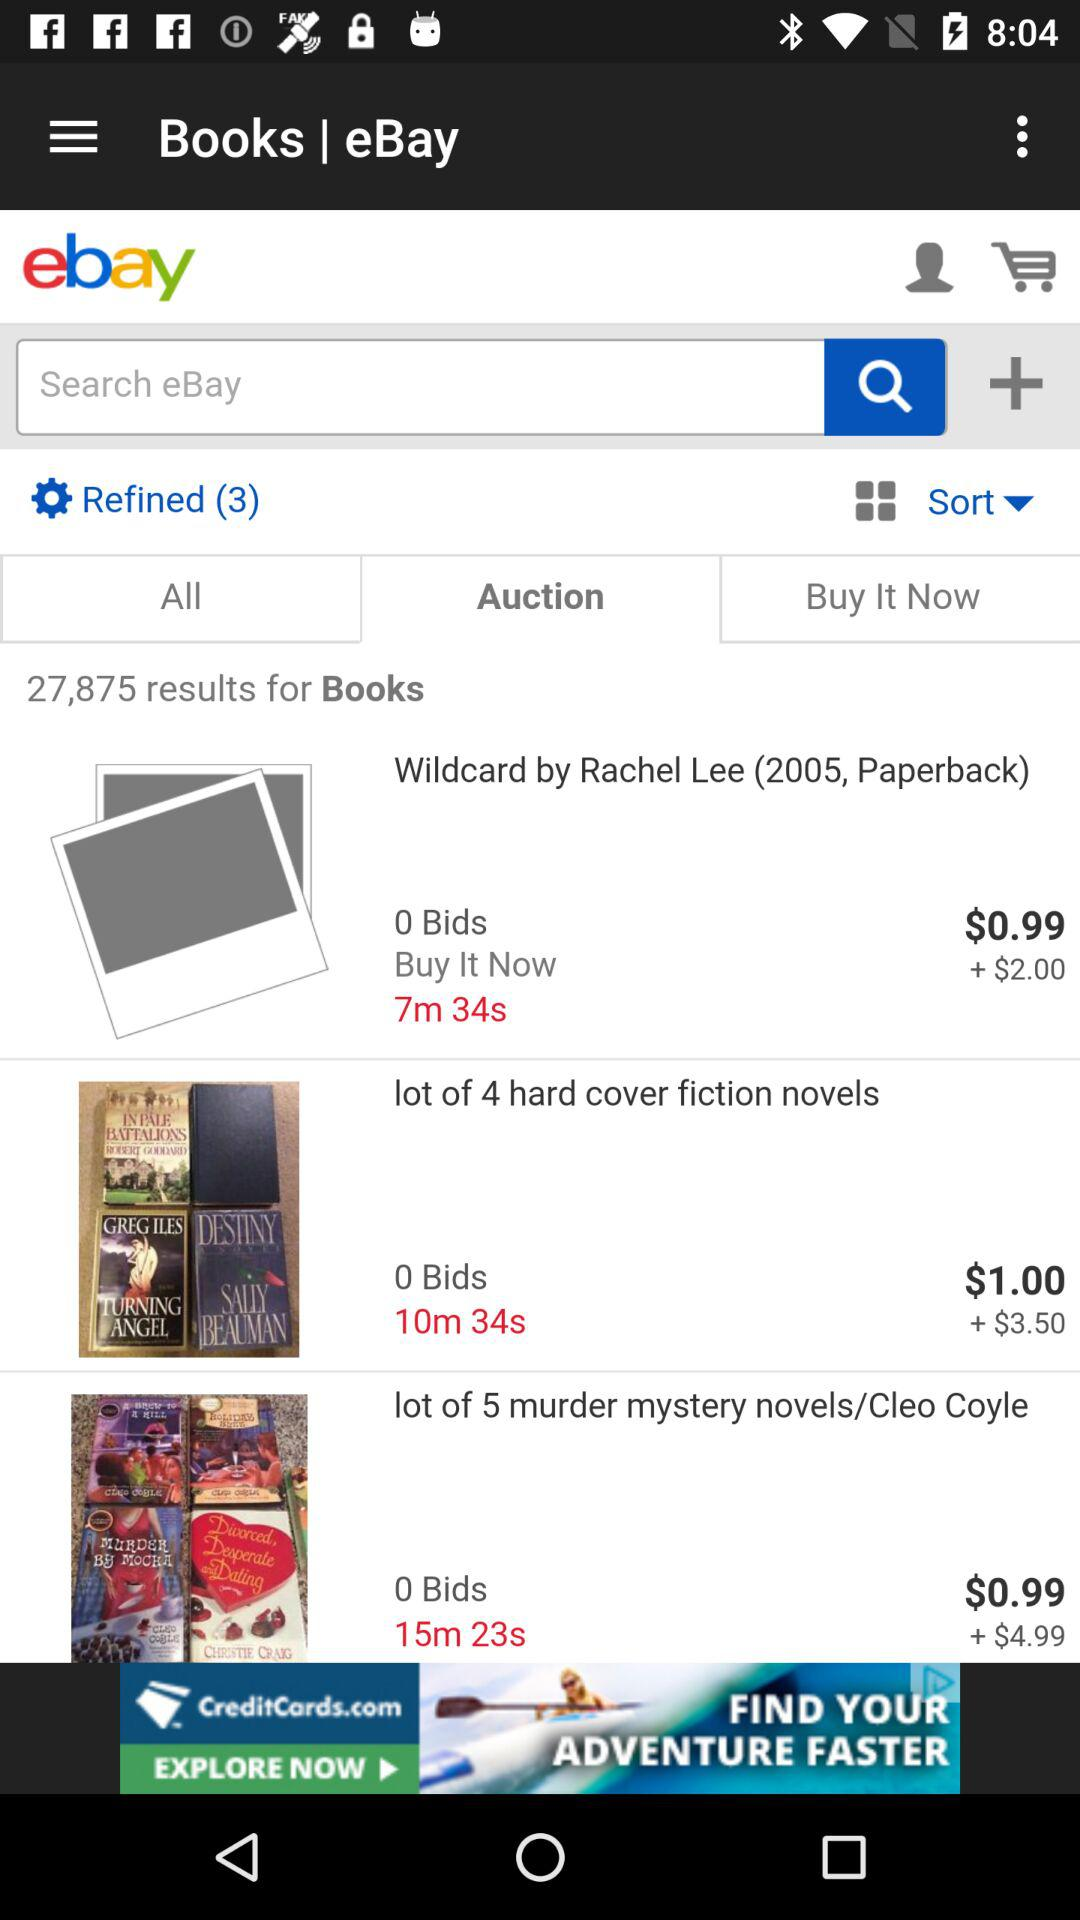What's the starting bid price for "lot of 4 hard cover fiction novels"? The starting bid price for "lot of 4 hard cover fiction novels" is $1. 